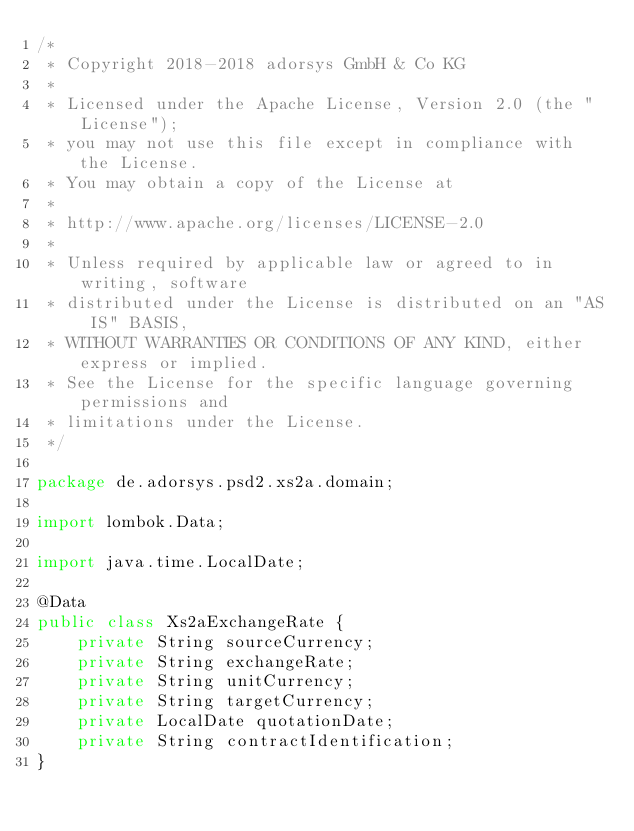<code> <loc_0><loc_0><loc_500><loc_500><_Java_>/*
 * Copyright 2018-2018 adorsys GmbH & Co KG
 *
 * Licensed under the Apache License, Version 2.0 (the "License");
 * you may not use this file except in compliance with the License.
 * You may obtain a copy of the License at
 *
 * http://www.apache.org/licenses/LICENSE-2.0
 *
 * Unless required by applicable law or agreed to in writing, software
 * distributed under the License is distributed on an "AS IS" BASIS,
 * WITHOUT WARRANTIES OR CONDITIONS OF ANY KIND, either express or implied.
 * See the License for the specific language governing permissions and
 * limitations under the License.
 */

package de.adorsys.psd2.xs2a.domain;

import lombok.Data;

import java.time.LocalDate;

@Data
public class Xs2aExchangeRate {
    private String sourceCurrency;
    private String exchangeRate;
    private String unitCurrency;
    private String targetCurrency;
    private LocalDate quotationDate;
    private String contractIdentification;
}
</code> 